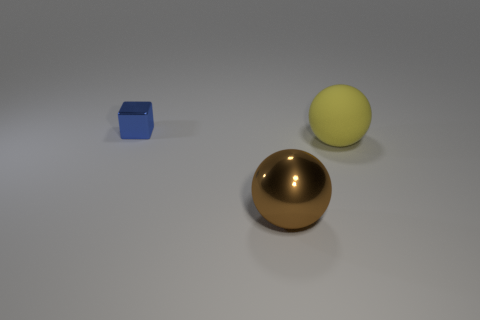Add 1 brown shiny spheres. How many objects exist? 4 Subtract all spheres. How many objects are left? 1 Subtract 0 yellow cylinders. How many objects are left? 3 Subtract all big yellow balls. Subtract all tiny objects. How many objects are left? 1 Add 2 yellow matte things. How many yellow matte things are left? 3 Add 2 big rubber things. How many big rubber things exist? 3 